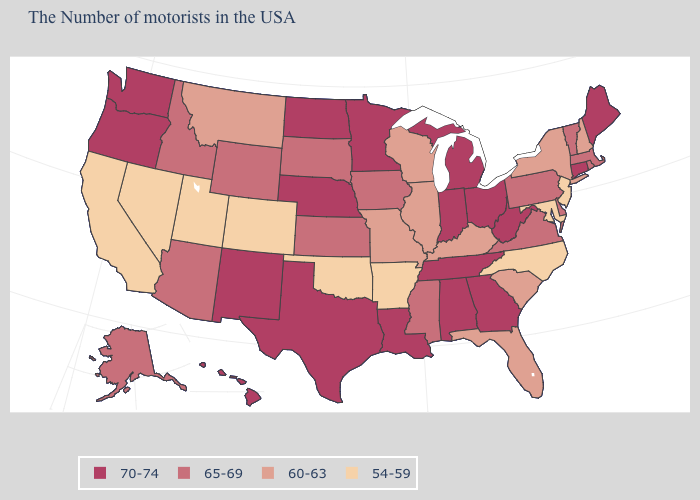Does the first symbol in the legend represent the smallest category?
Be succinct. No. Does Kentucky have a lower value than Maine?
Concise answer only. Yes. How many symbols are there in the legend?
Keep it brief. 4. Does the first symbol in the legend represent the smallest category?
Give a very brief answer. No. Is the legend a continuous bar?
Answer briefly. No. Name the states that have a value in the range 65-69?
Be succinct. Massachusetts, Rhode Island, Vermont, Delaware, Pennsylvania, Virginia, Mississippi, Iowa, Kansas, South Dakota, Wyoming, Arizona, Idaho, Alaska. What is the value of Pennsylvania?
Write a very short answer. 65-69. Name the states that have a value in the range 65-69?
Write a very short answer. Massachusetts, Rhode Island, Vermont, Delaware, Pennsylvania, Virginia, Mississippi, Iowa, Kansas, South Dakota, Wyoming, Arizona, Idaho, Alaska. What is the highest value in states that border Kentucky?
Short answer required. 70-74. Among the states that border New Mexico , which have the lowest value?
Give a very brief answer. Oklahoma, Colorado, Utah. Name the states that have a value in the range 65-69?
Short answer required. Massachusetts, Rhode Island, Vermont, Delaware, Pennsylvania, Virginia, Mississippi, Iowa, Kansas, South Dakota, Wyoming, Arizona, Idaho, Alaska. Name the states that have a value in the range 70-74?
Write a very short answer. Maine, Connecticut, West Virginia, Ohio, Georgia, Michigan, Indiana, Alabama, Tennessee, Louisiana, Minnesota, Nebraska, Texas, North Dakota, New Mexico, Washington, Oregon, Hawaii. What is the lowest value in the USA?
Concise answer only. 54-59. Does New York have the highest value in the Northeast?
Give a very brief answer. No. 